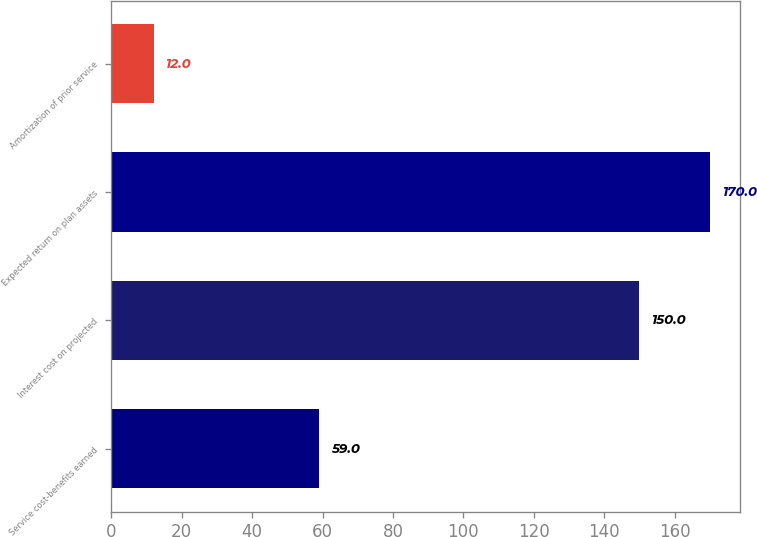Convert chart. <chart><loc_0><loc_0><loc_500><loc_500><bar_chart><fcel>Service cost-benefits earned<fcel>Interest cost on projected<fcel>Expected return on plan assets<fcel>Amortization of prior service<nl><fcel>59<fcel>150<fcel>170<fcel>12<nl></chart> 